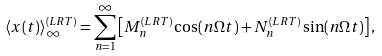<formula> <loc_0><loc_0><loc_500><loc_500>\langle x ( t ) \rangle ^ { ( L R T ) } _ { \infty } = \sum _ { n = 1 } ^ { \infty } \left [ M _ { n } ^ { ( L R T ) } \cos ( n \Omega t ) + N _ { n } ^ { ( L R T ) } \sin ( n \Omega t ) \right ] ,</formula> 